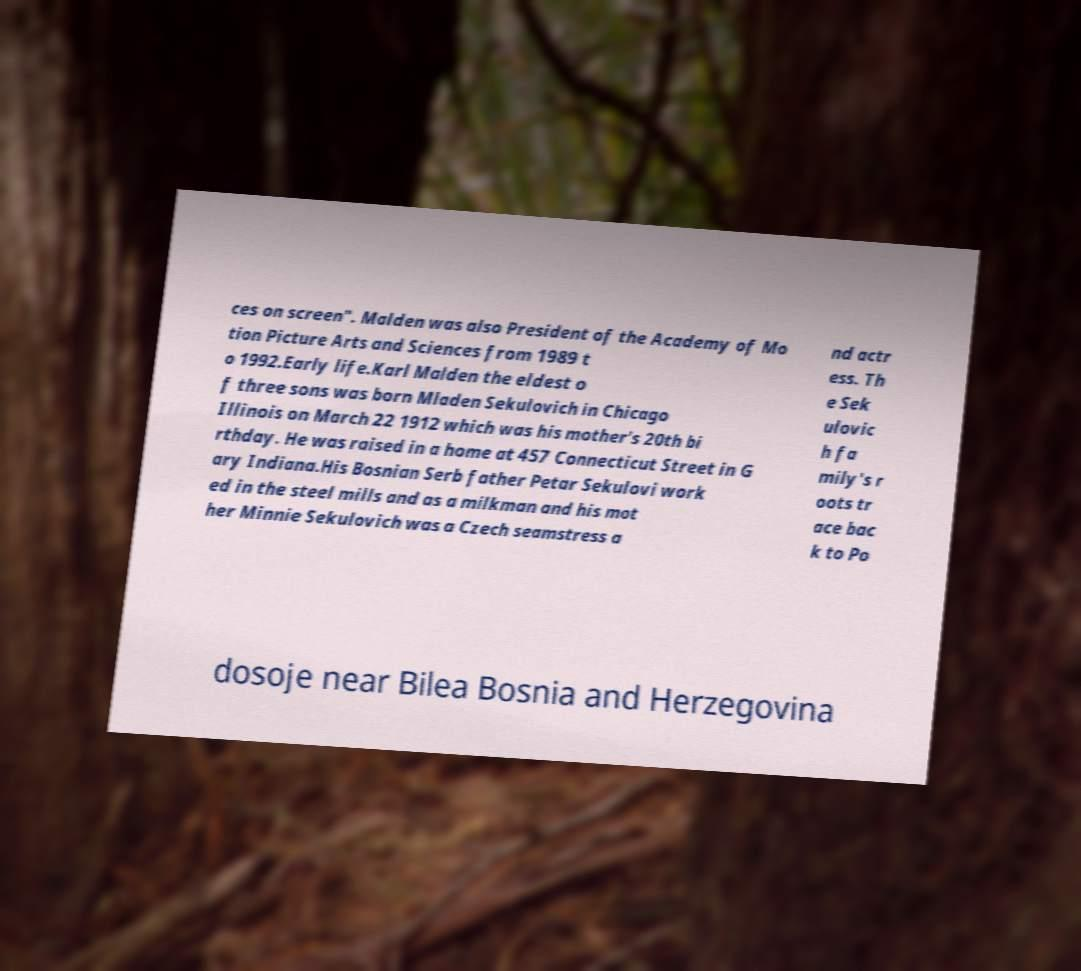Can you accurately transcribe the text from the provided image for me? ces on screen". Malden was also President of the Academy of Mo tion Picture Arts and Sciences from 1989 t o 1992.Early life.Karl Malden the eldest o f three sons was born Mladen Sekulovich in Chicago Illinois on March 22 1912 which was his mother's 20th bi rthday. He was raised in a home at 457 Connecticut Street in G ary Indiana.His Bosnian Serb father Petar Sekulovi work ed in the steel mills and as a milkman and his mot her Minnie Sekulovich was a Czech seamstress a nd actr ess. Th e Sek ulovic h fa mily's r oots tr ace bac k to Po dosoje near Bilea Bosnia and Herzegovina 